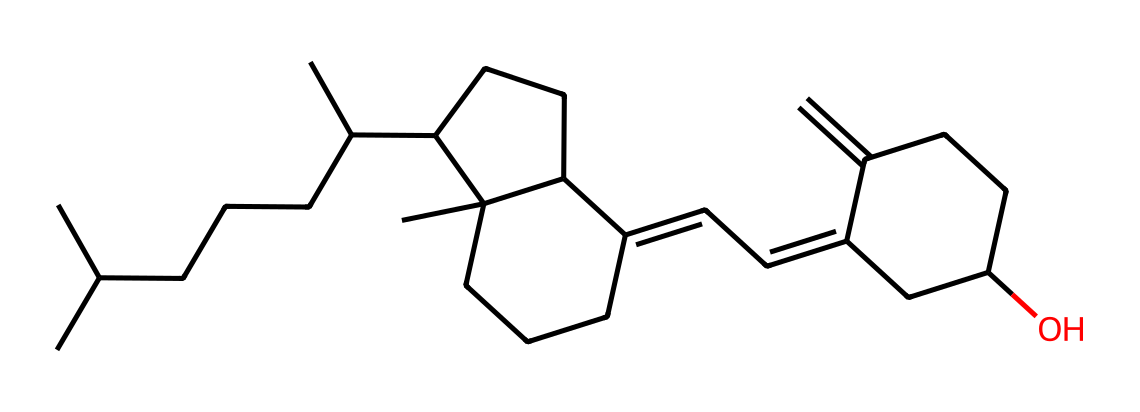What is the name of this vitamin? The SMILES representation corresponds to the molecular structure of cholecalciferol, which is commonly known as vitamin D3.
Answer: vitamin D3 How many carbon atoms are present in this structure? Counting from the SMILES representation, there are 27 carbon atoms in total.
Answer: 27 Does this vitamin contain any oxygen atoms? By analyzing the SMILES, we observe that there is one oxygen atom present in the structure.
Answer: yes What type of compound is vitamin D3 classified as? Vitamin D3 is classified as a secosteroid, which is a type of steroid that contains a broken ring structure.
Answer: secosteroid What functional group is visible in this chemical structure? The alcohol functional group (-OH) is present in vitamin D3, which is indicated by the 'O' connected to a carbon chain.
Answer: alcohol How many double bonds are present in the structure? In the SMILES, there are three double bonds indicated, which can be observed in the ring and side chain.
Answer: 3 What role does vitamin D3 play in the human body? Vitamin D3 plays a crucial role in calcium metabolism and bone health as it helps in calcium absorption.
Answer: calcium metabolism 